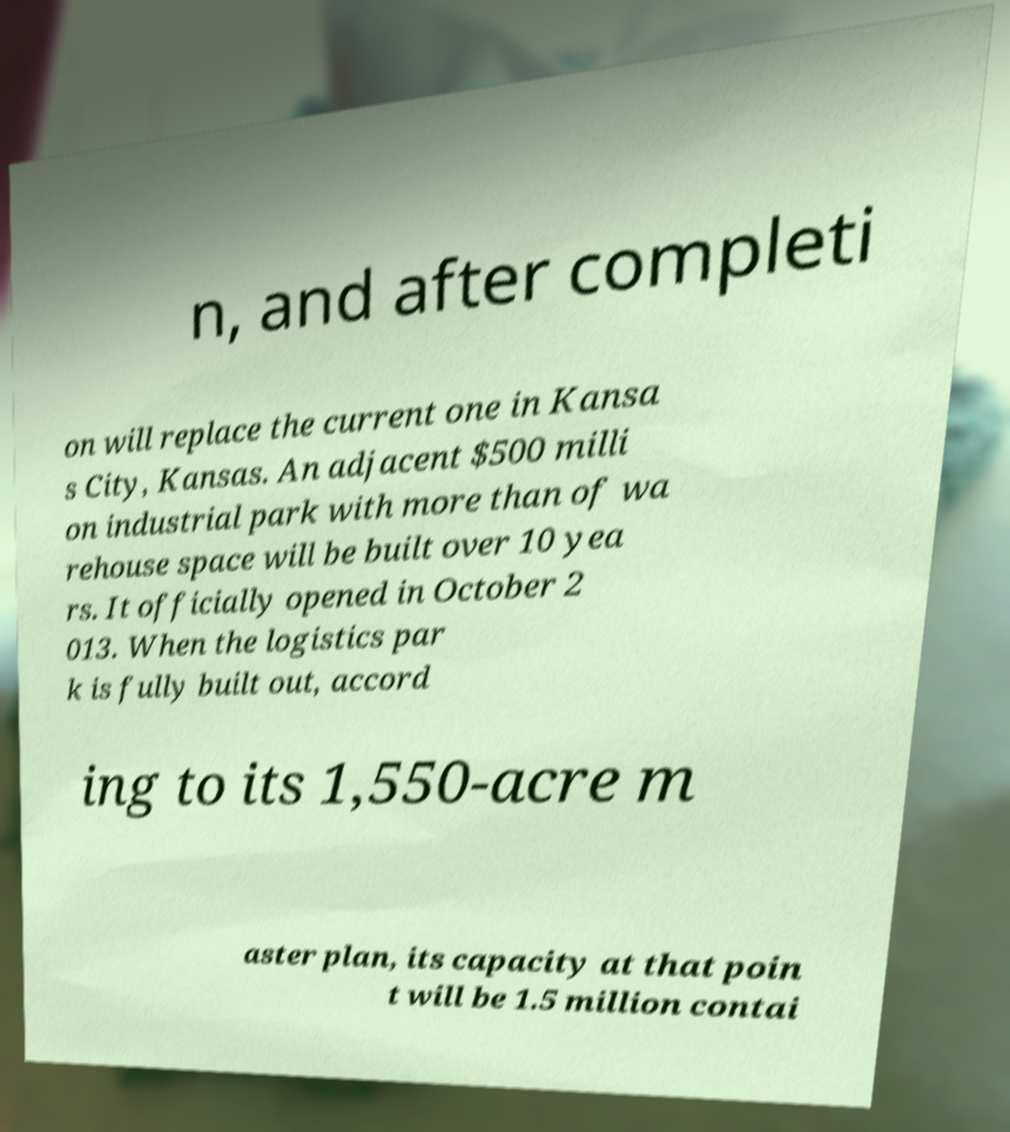Could you extract and type out the text from this image? n, and after completi on will replace the current one in Kansa s City, Kansas. An adjacent $500 milli on industrial park with more than of wa rehouse space will be built over 10 yea rs. It officially opened in October 2 013. When the logistics par k is fully built out, accord ing to its 1,550-acre m aster plan, its capacity at that poin t will be 1.5 million contai 